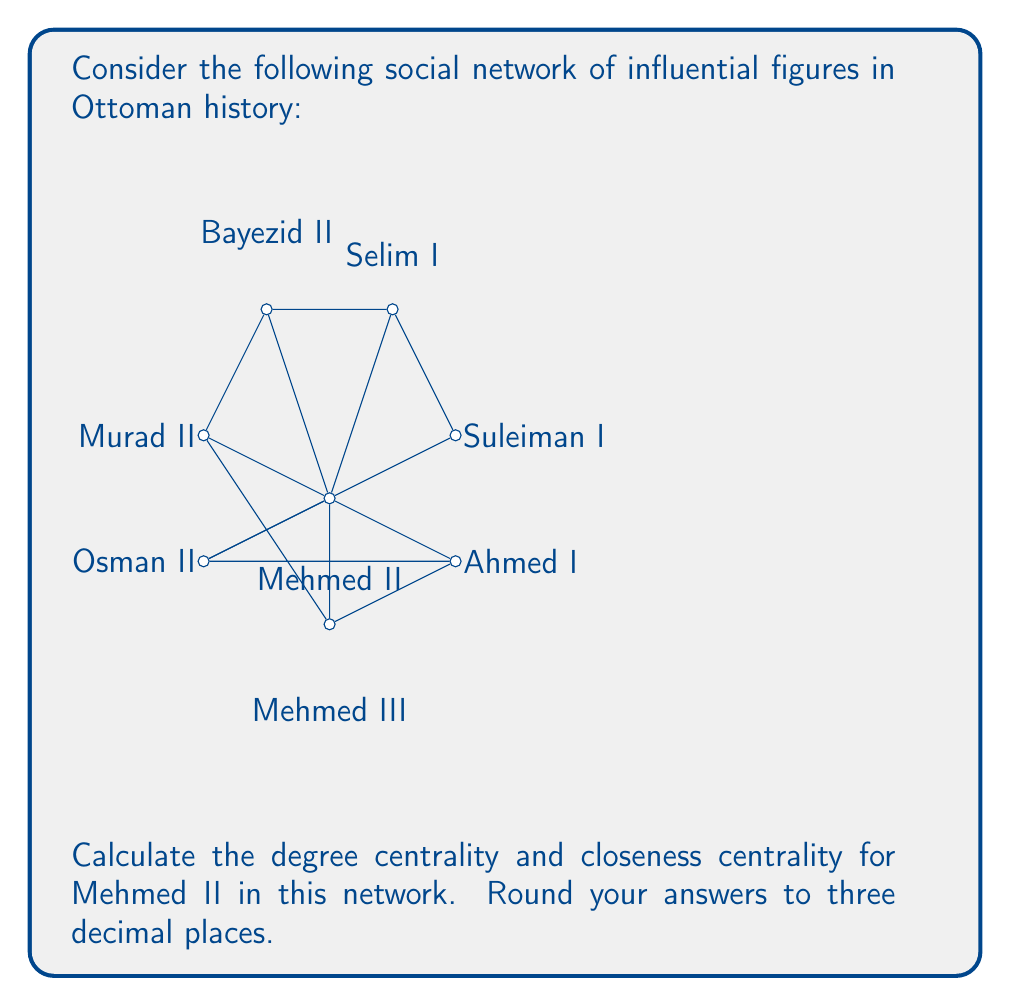Teach me how to tackle this problem. To solve this problem, we'll calculate both the degree centrality and closeness centrality for Mehmed II.

1. Degree Centrality:
Degree centrality is the number of direct connections a node has, normalized by the maximum possible connections.

For Mehmed II:
- Number of direct connections: 7
- Total number of nodes: 8
- Maximum possible connections: 7 (n-1, where n is the total number of nodes)

Degree Centrality = $\frac{\text{Number of connections}}{\text{Maximum possible connections}} = \frac{7}{7} = 1$

2. Closeness Centrality:
Closeness centrality measures how close a node is to all other nodes in the network. It's calculated as the inverse of the average shortest path length to all other nodes.

For Mehmed II:
- Distance to Suleiman I, Selim I, Bayezid II, Murad II, Mehmed III, Ahmed I, Osman II: 1 (direct connections)
- Total distance: 7
- Number of other nodes: 7

Average shortest path length = $\frac{7}{7} = 1$

Closeness Centrality = $\frac{1}{\text{Average shortest path length}} = \frac{1}{1} = 1$

Rounding both results to three decimal places:
Degree Centrality: 1.000
Closeness Centrality: 1.000
Answer: Degree Centrality: 1.000, Closeness Centrality: 1.000 